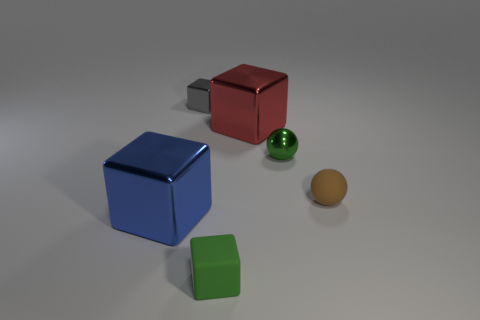What is the size of the green ball that is the same material as the red thing?
Offer a very short reply. Small. How many objects are tiny metal things that are to the left of the red metal object or metallic blocks that are left of the gray object?
Offer a very short reply. 2. Is the size of the green metallic ball in front of the gray metal thing the same as the tiny matte cube?
Give a very brief answer. Yes. There is a large object behind the small shiny sphere; what is its color?
Offer a terse response. Red. What color is the small rubber object that is the same shape as the red metallic object?
Give a very brief answer. Green. How many small brown spheres are in front of the block behind the big cube that is behind the blue metallic cube?
Your answer should be very brief. 1. Is the number of tiny green matte things that are behind the small metal ball less than the number of tiny red rubber cylinders?
Your answer should be very brief. No. Does the tiny metallic sphere have the same color as the rubber cube?
Offer a very short reply. Yes. There is a green shiny object that is the same shape as the small brown rubber thing; what size is it?
Give a very brief answer. Small. What number of green blocks have the same material as the small brown object?
Give a very brief answer. 1. 